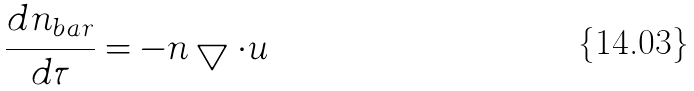<formula> <loc_0><loc_0><loc_500><loc_500>\frac { d n _ { b a r } } { d \tau } = - n \bigtriangledown \cdot u</formula> 